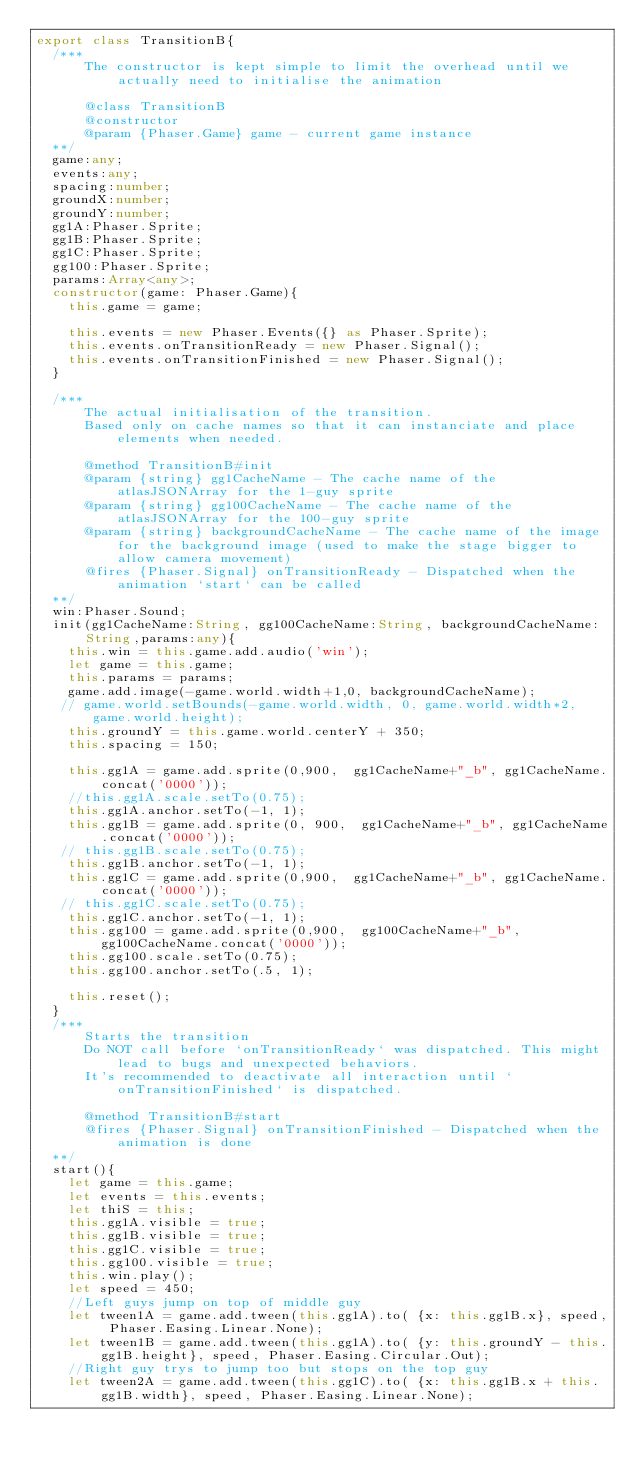Convert code to text. <code><loc_0><loc_0><loc_500><loc_500><_TypeScript_>export class TransitionB{
  /***
      The constructor is kept simple to limit the overhead until we actually need to initialise the animation

      @class TransitionB
      @constructor
      @param {Phaser.Game} game - current game instance
  **/
  game:any;
  events:any;
  spacing:number;
  groundX:number;
  groundY:number;
  gg1A:Phaser.Sprite;
  gg1B:Phaser.Sprite;
  gg1C:Phaser.Sprite;
  gg100:Phaser.Sprite;
  params:Array<any>;
  constructor(game: Phaser.Game){
    this.game = game;

    this.events = new Phaser.Events({} as Phaser.Sprite);
    this.events.onTransitionReady = new Phaser.Signal();
    this.events.onTransitionFinished = new Phaser.Signal();
  }

  /***
      The actual initialisation of the transition.
      Based only on cache names so that it can instanciate and place elements when needed.

      @method TransitionB#init
      @param {string} gg1CacheName - The cache name of the atlasJSONArray for the 1-guy sprite
      @param {string} gg100CacheName - The cache name of the atlasJSONArray for the 100-guy sprite
      @param {string} backgroundCacheName - The cache name of the image for the background image (used to make the stage bigger to allow camera movement)
      @fires {Phaser.Signal} onTransitionReady - Dispatched when the animation `start` can be called
  **/
  win:Phaser.Sound;
  init(gg1CacheName:String, gg100CacheName:String, backgroundCacheName:String,params:any){
    this.win = this.game.add.audio('win');
    let game = this.game;
    this.params = params;
    game.add.image(-game.world.width+1,0, backgroundCacheName);
   // game.world.setBounds(-game.world.width, 0, game.world.width*2, game.world.height);
    this.groundY = this.game.world.centerY + 350;
    this.spacing = 150;
    
    this.gg1A = game.add.sprite(0,900,  gg1CacheName+"_b", gg1CacheName.concat('0000'));
    //this.gg1A.scale.setTo(0.75);
    this.gg1A.anchor.setTo(-1, 1);
    this.gg1B = game.add.sprite(0, 900,  gg1CacheName+"_b", gg1CacheName.concat('0000'));
   // this.gg1B.scale.setTo(0.75);
    this.gg1B.anchor.setTo(-1, 1);
    this.gg1C = game.add.sprite(0,900,  gg1CacheName+"_b", gg1CacheName.concat('0000'));
   // this.gg1C.scale.setTo(0.75);
    this.gg1C.anchor.setTo(-1, 1);
    this.gg100 = game.add.sprite(0,900,  gg100CacheName+"_b", gg100CacheName.concat('0000'));
    this.gg100.scale.setTo(0.75);
    this.gg100.anchor.setTo(.5, 1);

    this.reset();
  }
  /***
      Starts the transition
      Do NOT call before `onTransitionReady` was dispatched. This might lead to bugs and unexpected behaviors.
      It's recommended to deactivate all interaction until `onTransitionFinished` is dispatched.

      @method TransitionB#start
      @fires {Phaser.Signal} onTransitionFinished - Dispatched when the animation is done
  **/
  start(){
    let game = this.game;
    let events = this.events;
    let thiS = this;
    this.gg1A.visible = true;
    this.gg1B.visible = true;
    this.gg1C.visible = true;
    this.gg100.visible = true;
    this.win.play();
    let speed = 450;
    //Left guys jump on top of middle guy
    let tween1A = game.add.tween(this.gg1A).to( {x: this.gg1B.x}, speed, Phaser.Easing.Linear.None);
    let tween1B = game.add.tween(this.gg1A).to( {y: this.groundY - this.gg1B.height}, speed, Phaser.Easing.Circular.Out);
    //Right guy trys to jump too but stops on the top guy
    let tween2A = game.add.tween(this.gg1C).to( {x: this.gg1B.x + this.gg1B.width}, speed, Phaser.Easing.Linear.None);</code> 